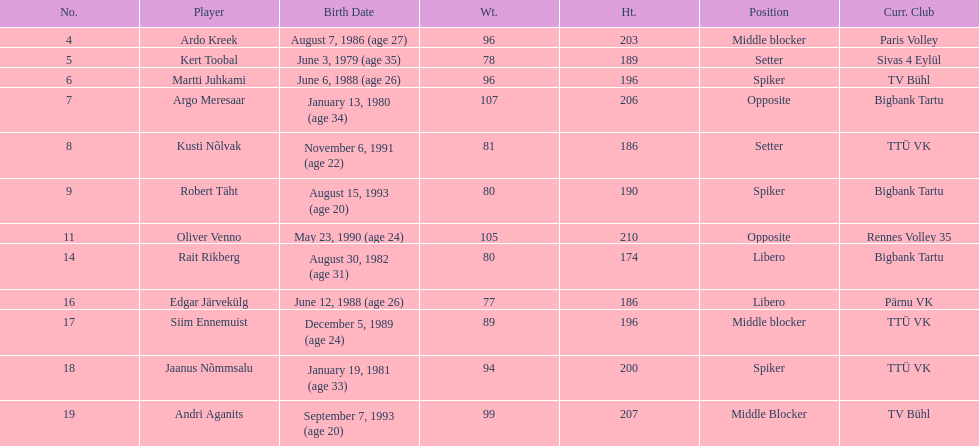On the men's national volleyball team of estonia, which player is the tallest? Oliver Venno. 